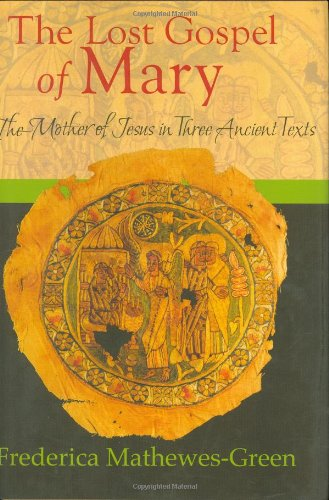Who wrote this book? The book 'The Lost Gospel of Mary' was authored by Frederica Mathewes-Green, a well-known writer and commentator on religious subjects. 